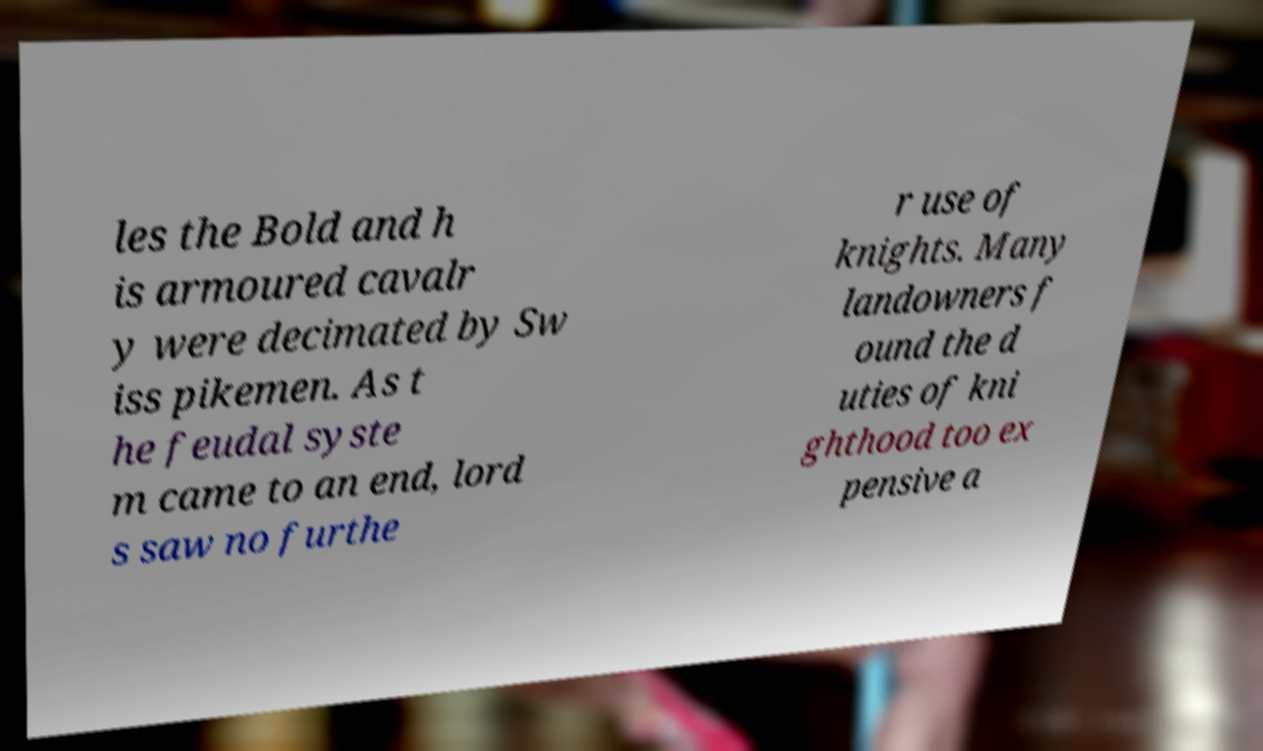What messages or text are displayed in this image? I need them in a readable, typed format. les the Bold and h is armoured cavalr y were decimated by Sw iss pikemen. As t he feudal syste m came to an end, lord s saw no furthe r use of knights. Many landowners f ound the d uties of kni ghthood too ex pensive a 